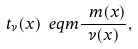Convert formula to latex. <formula><loc_0><loc_0><loc_500><loc_500>t _ { \nu } ( x ) \ e q m \frac { \ m ( x ) } { \nu ( x ) } ,</formula> 